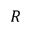Convert formula to latex. <formula><loc_0><loc_0><loc_500><loc_500>R</formula> 